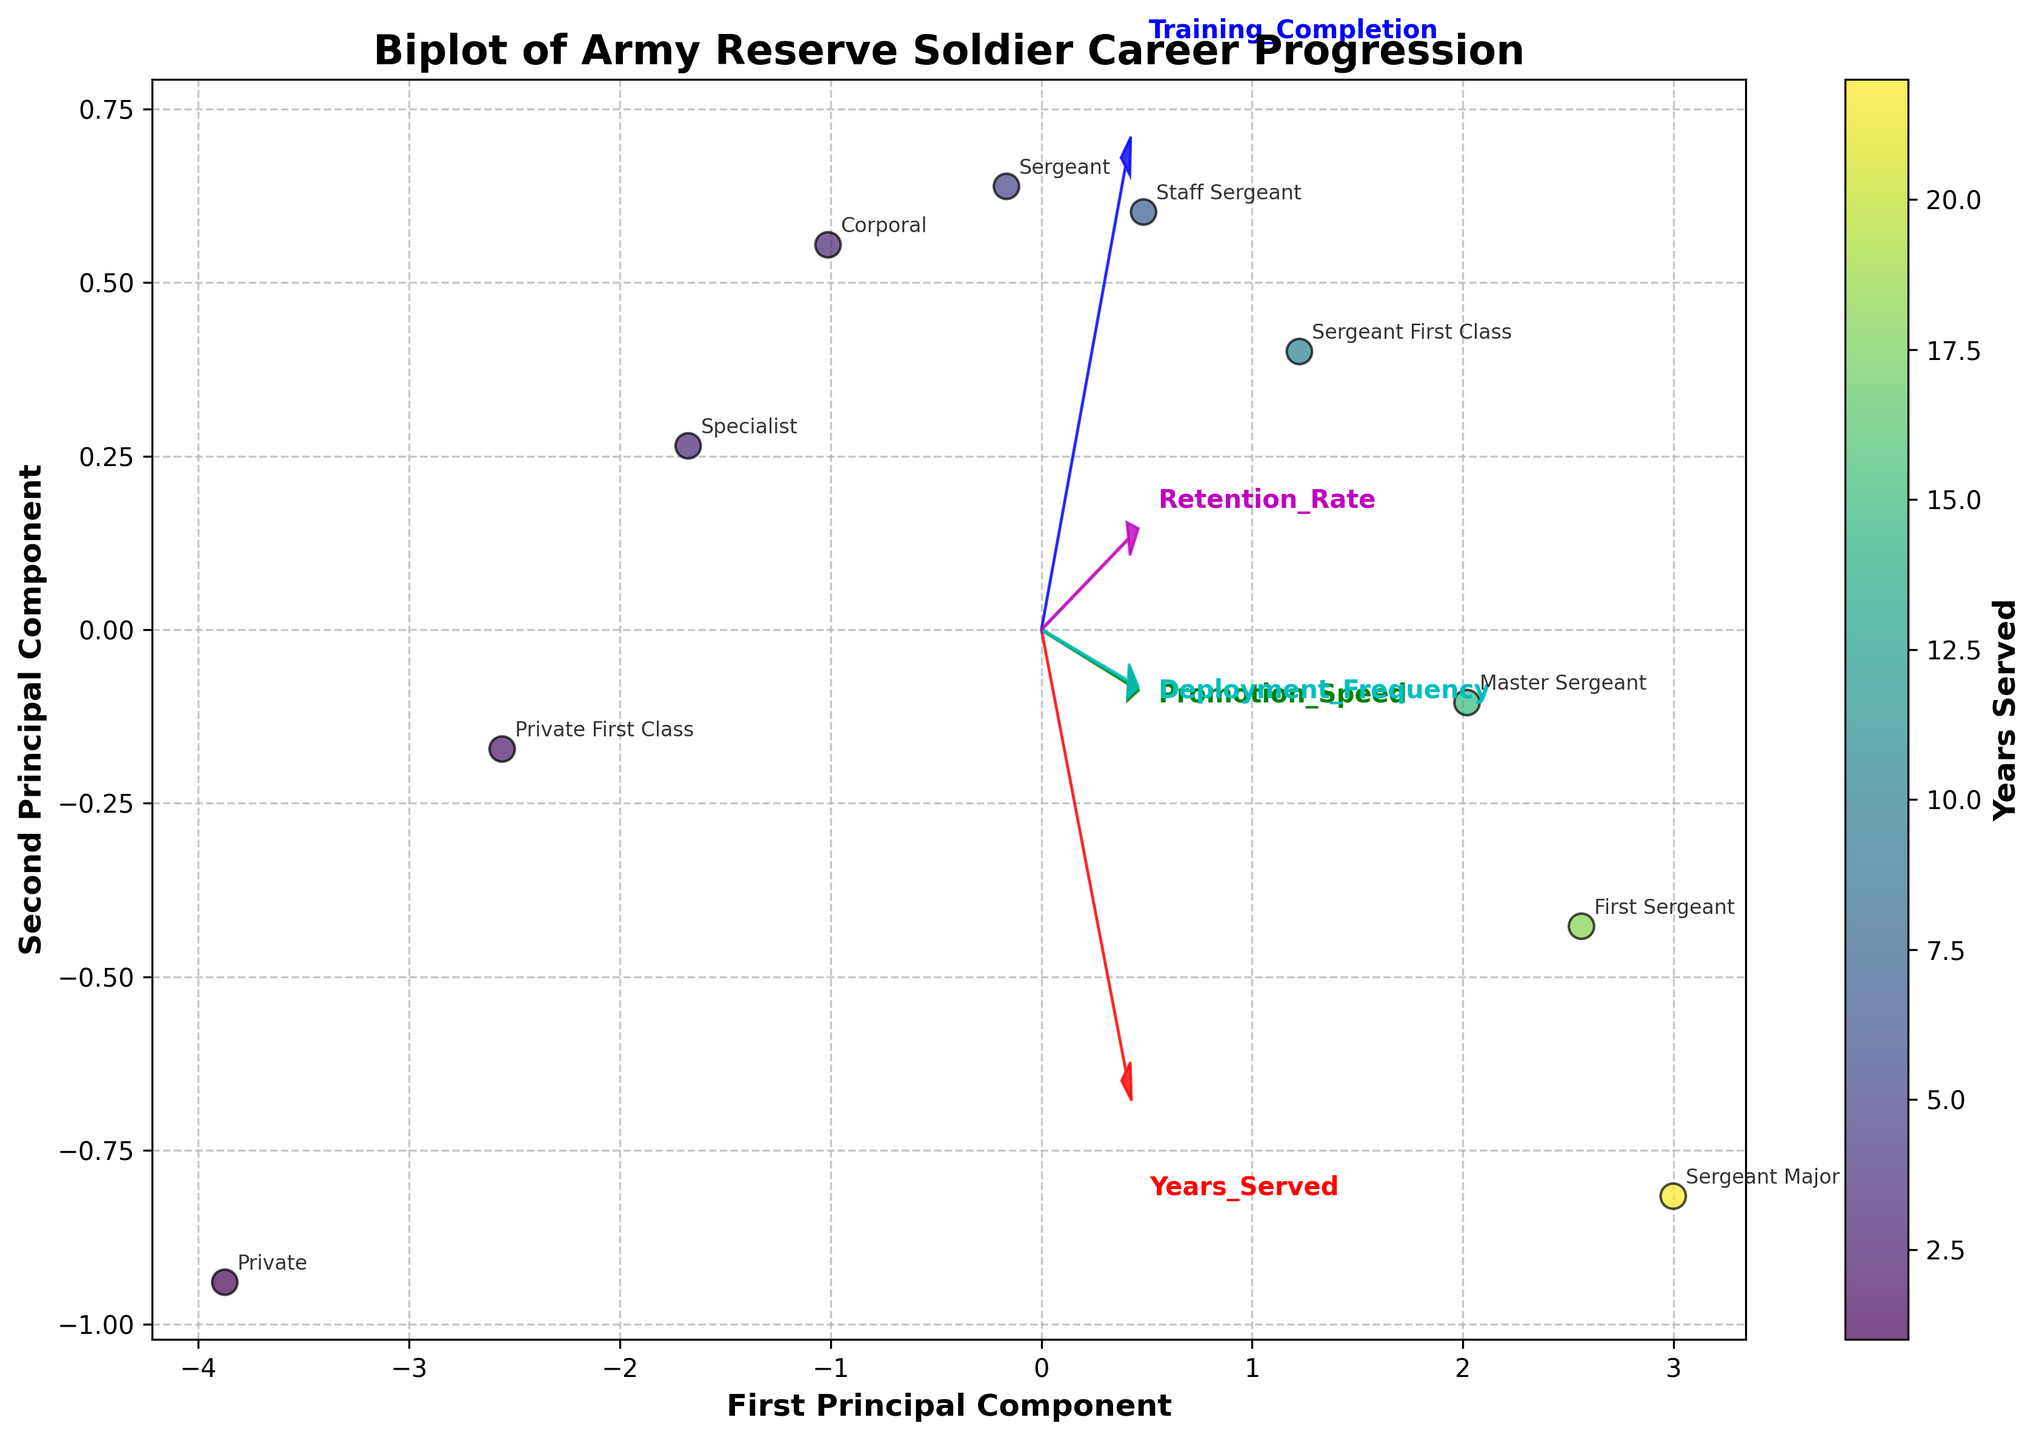What is the title of the figure? The title is typically shown at the top of the figure and describes the main topic of the plot. The title in this case is "Biplot of Army Reserve Soldier Career Progression."
Answer: Biplot of Army Reserve Soldier Career Progression How many data points are plotted in the figure? Each data point represents a rank, and we can count the number of distinct ranks annotated around the scatter points. There are 10 ranks listed in the data.
Answer: 10 Which feature vectors are shown in the plot? Feature vectors are indicated by arrows with text labels. The features shown here are 'Years_Served', 'Promotion_Speed', 'Training_Completion', 'Deployment_Frequency', and 'Retention_Rate.'
Answer: Years_Served, Promotion_Speed, Training_Completion, Deployment_Frequency, Retention_Rate Which rank corresponds to the data point plotted furthest to the right? The points are scattered, and the rightmost data point is annotated. This corresponds to the 'Sergeant Major' rank.
Answer: Sergeant Major What color represents the longest years served, according to the colorbar? The colorbar shows a gradient indicating different years served. The color representing the longest years served (22 years) is towards the brighter end of the Viridis color map.
Answer: Brighter end of the color map Which rank has the highest PC1 value? By examining the scatter plot, we see which rank is plotted furthest along the PC1 axis. The rank with the highest PC1 value is "Sergeant Major."
Answer: Sergeant Major What is the relationship between Promotion_Speed and Retention_Rate based on the direction of the feature vectors? The direction of the arrows for 'Promotion_Speed' and 'Retention_Rate' seem to indicate a positive correlation because their arrows point in a similar direction.
Answer: Positive correlation Which rank has the lowest Retention_Rate, and how can you tell? The color corresponding to the smallest dot represents the lowest Retention_Rate. By checking the annotation and Retention_Rate values, the rank 'Private' has the lowest retention rate.
Answer: Private What feature does the red arrow represent, and in which direction does it point? The feature vectors are color-coded, and the red arrow points to the 'Years_Served.' The direction is upwards and to the right.
Answer: Years_Served, upwards and to the right How does the 'Training_Completion' feature vector influence the plot? The 'Training_Completion' arrow, represented in blue, points upwards, indicating that higher values for this feature are associated with higher values on the second principal component (PC2).
Answer: Higher PC2 values 